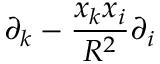<formula> <loc_0><loc_0><loc_500><loc_500>\partial _ { k } - { \frac { x _ { k } x _ { i } } { R ^ { 2 } } } \partial _ { i }</formula> 